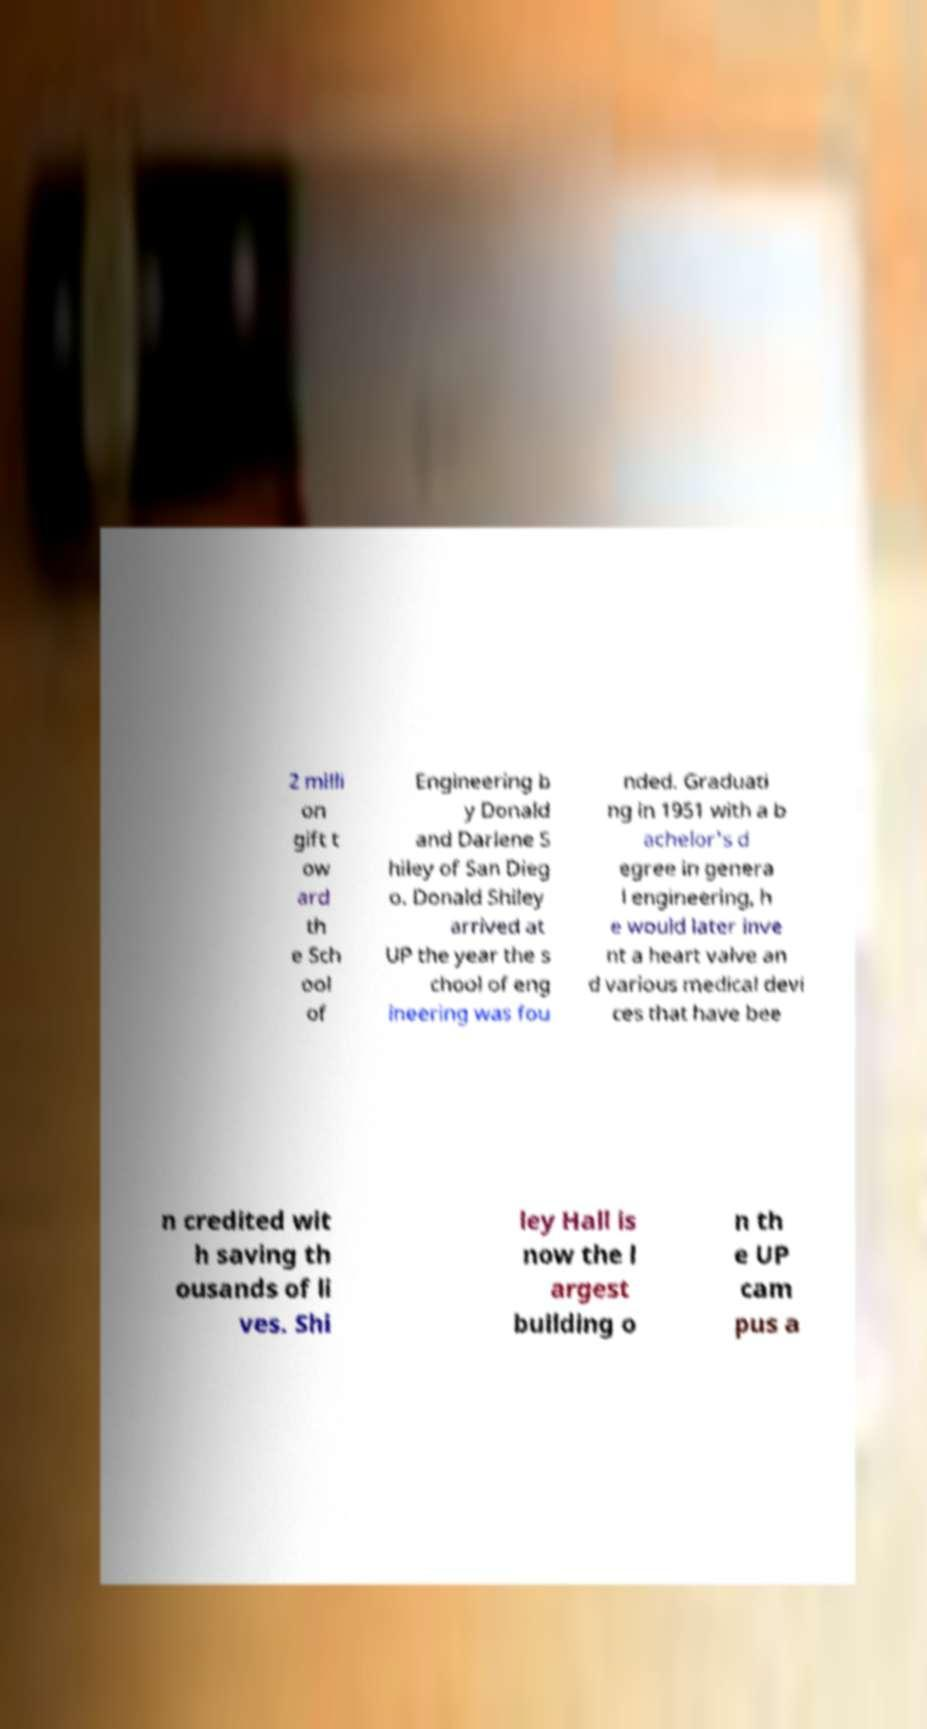For documentation purposes, I need the text within this image transcribed. Could you provide that? 2 milli on gift t ow ard th e Sch ool of Engineering b y Donald and Darlene S hiley of San Dieg o. Donald Shiley arrived at UP the year the s chool of eng ineering was fou nded. Graduati ng in 1951 with a b achelor's d egree in genera l engineering, h e would later inve nt a heart valve an d various medical devi ces that have bee n credited wit h saving th ousands of li ves. Shi ley Hall is now the l argest building o n th e UP cam pus a 